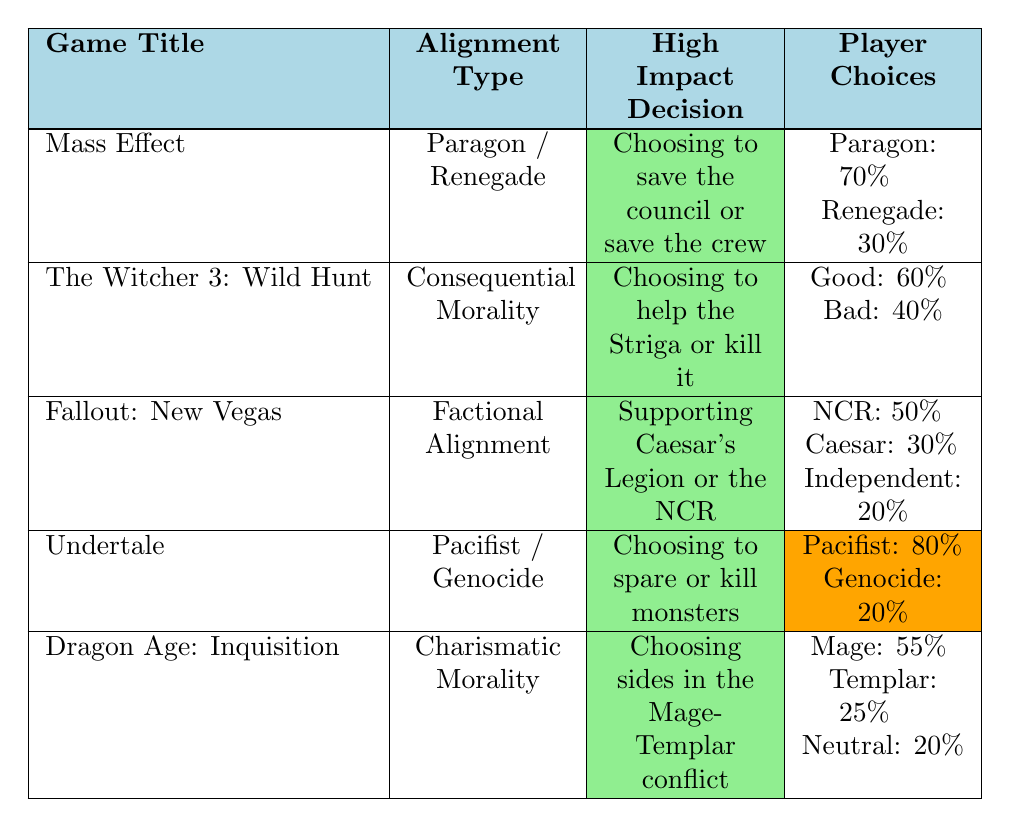What is the alignment type used in "Undertale"? The table lists "Undertale" under the column for Alignment Type, which shows "Pacifist / Genocide".
Answer: Pacifist / Genocide Which game has the highest percentage of good player choices? In the "Player Choices" section of the table, "The Witcher 3: Wild Hunt" has 60% labeled as good choices, which is higher than the others.
Answer: The Witcher 3: Wild Hunt What is the total percentage of player choices supporting factions in "Fallout: New Vegas"? By adding the percentages of NCR (50%), Caesar (30%), and Independent (20%), the total is 50 + 30 + 20 = 100%.
Answer: 100% Is the alignment shift for the high impact decision in "Mass Effect" significant? The table states that the alignment shift for "Choosing to save the council or save the crew" is labeled as "Significant".
Answer: Yes Which game has a high impact decision with a medium alignment shift? From the table, both "Mass Effect" and "The Witcher 3: Wild Hunt" feature high impact decisions with medium alignment shifts. Mass Effect's second decision shifts moderately, and so does The Witcher 3's.
Answer: Mass Effect and The Witcher 3: Wild Hunt If a player supports the Mages in "Dragon Age: Inquisition", what percentage of players do they represent? The table shows that 55% of the player choices support Mages.
Answer: 55% Which game features a decision about saving a crew or a council? The decision mentioned in the table for "Mass Effect" involves saving the council or saving the crew.
Answer: Mass Effect What is the average percentage between the good choices in "The Witcher 3: Wild Hunt" and the player choices for "Undertale"? To find the average, first collect the good choices (60%) from "The Witcher 3" and the pacifist runs (80%) from "Undertale". Then, (60 + 80) / 2 = 70%.
Answer: 70% How does the player choice distribution in "Fallout: New Vegas" compare to that of "Mass Effect"? In "Fallout: New Vegas", the distribution is NCR: 50%, Caesar: 30%, and Independent: 20%. In "Mass Effect", the distribution is Paragon: 70% and Renegade: 30%. Compared to Mass Effect's higher paragon choice, Fallout shows a more balanced faction support.
Answer: Fallout: More balanced; Mass Effect: higher Paragon Which game features the decision point regarding the Mage-Templar conflict? The table specifies that "Dragon Age: Inquisition" includes the decision point about choosing sides in the Mage-Templar conflict.
Answer: Dragon Age: Inquisition 